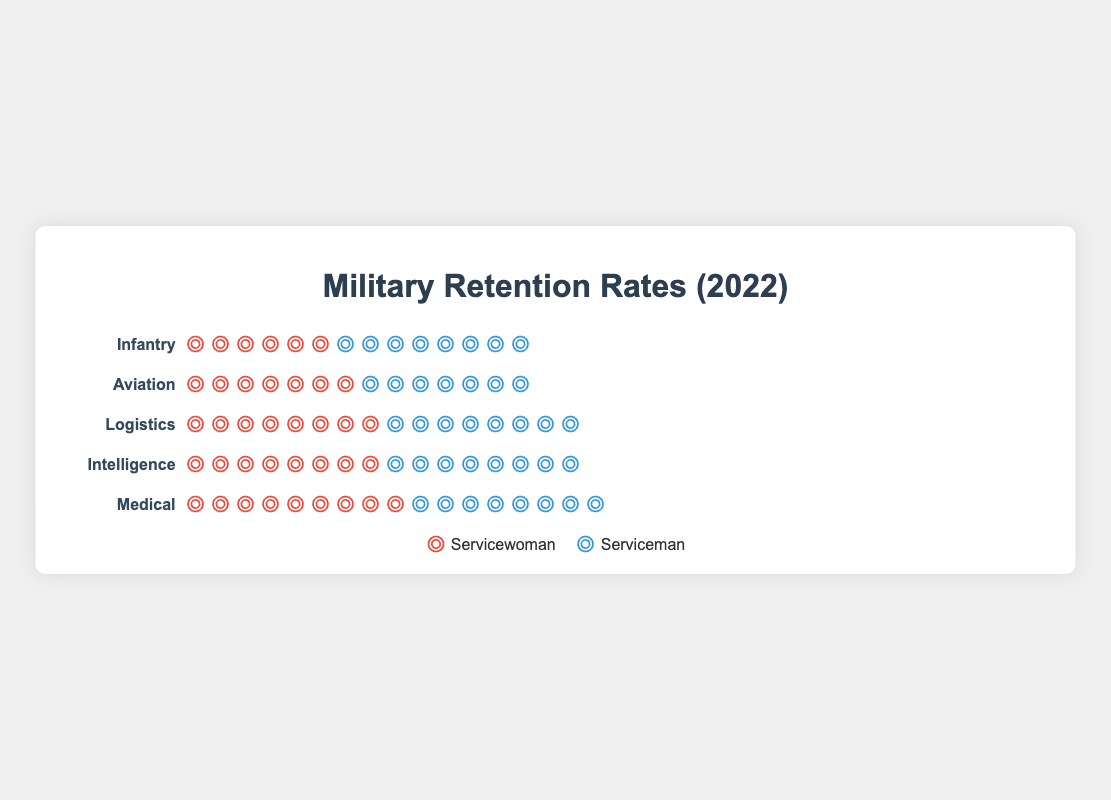How is the retention rate visualized for each occupation? The retention rate for each occupation is represented by the number of icons. Red icons represent servicewomen, and blue icons represent servicemen. Each icon represents a 10% retention rate.
Answer: Icons Which occupation shows the highest retention rate for servicewomen? By comparing the number of red icons, the Medical occupation has the highest retention rate with 8.9 icons (89%).
Answer: Medical What is the retention rate difference between servicewomen and servicemen in the Infantry occupation? The retention rate for servicewomen in Infantry is shown by 6.8 red icons (68%), and for servicemen, it is shown by 8.2 blue icons (82%). The difference is 8.2 - 6.8 = 1.4 icons, which corresponds to 14%.
Answer: 14% Which occupation has a higher retention rate for servicewomen than servicemen? By examining the icons, the Intelligence occupation has 8.5 red icons (85%) for servicewomen and 8.3 blue icons (83%) for servicemen. Thus, servicewomen have a higher retention rate in Intelligence.
Answer: Intelligence Compare the retention rates in the Medical and Logistics occupations for servicewomen. Which is higher and by how much? The Medical occupation has 8.9 red icons (89%) while the Logistics occupation has 8.1 red icons (81%). The difference is 8.9 - 8.1 = 0.8 icons, which corresponds to 8%. So, Medical has a higher retention rate by 8%.
Answer: Medical by 8% What can be inferred about the retention rates of servicewomen compared to servicemen in all occupations? Retention rates for servicewomen are generally lower than servicemen in Infantry, Aviation, and Logistics, but higher in Intelligence and Medical. This suggests a variation in retention rates based on occupation.
Answer: Servicewomen's retention varies by occupation Which occupation has the smallest retention rate difference between servicewomen and servicemen? Aviation shows 7.5 red icons (75%) for servicewomen and 7.9 blue icons (79%) for servicemen, giving a difference of 0.4 icons, or 4%. This is the smallest difference.
Answer: Aviation Between the Infantry and Medical occupations, which has the highest overall retention rate considering both servicewomen and servicemen? Summing the retention rates, Infantry has 68% (servicewomen) + 82% (servicemen) = 150%, while Medical has 89% (servicewomen) + 86% (servicemen) = 175%. Medical has the highest overall retention rate.
Answer: Medical 